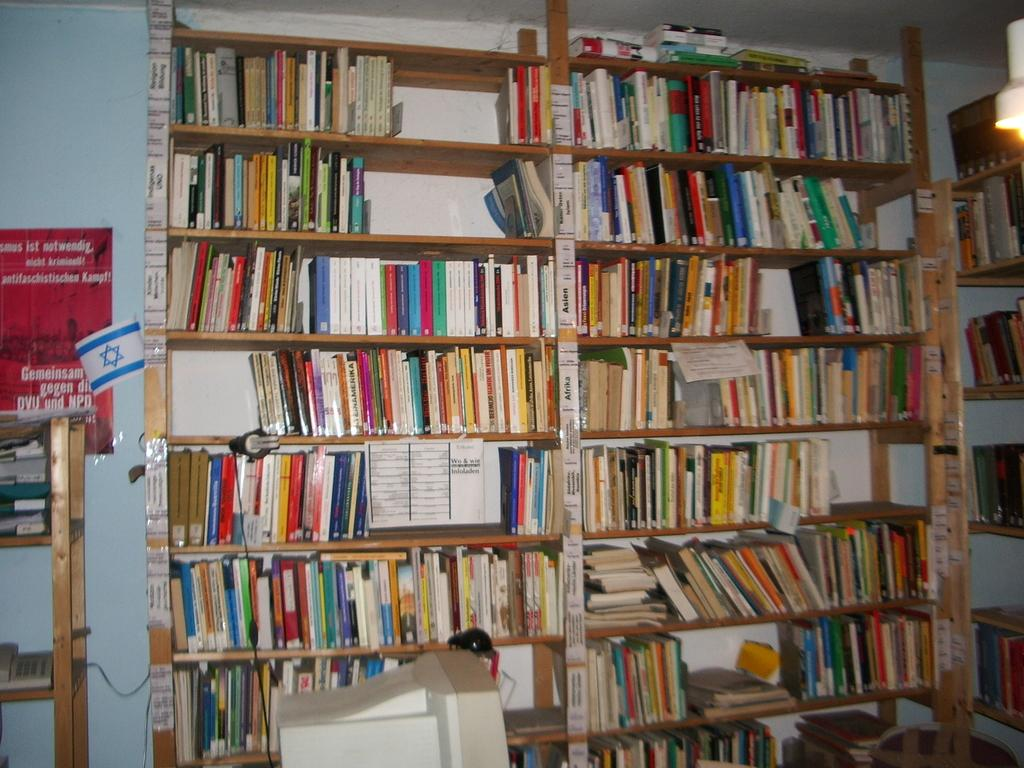What type of furniture is present in the image? There are shelves in the image. What can be found on the shelves? The shelves contain books and other objects. What is on the wall in the image? The wall has a poster on it. What type of electronic device is visible in the image? There is a computer monitor in the image. Can you see a giraffe in the image? No, there is no giraffe present in the image. Which direction is the animal facing in the image? There is no animal present in the image, so it is not possible to determine the direction it might be facing. 